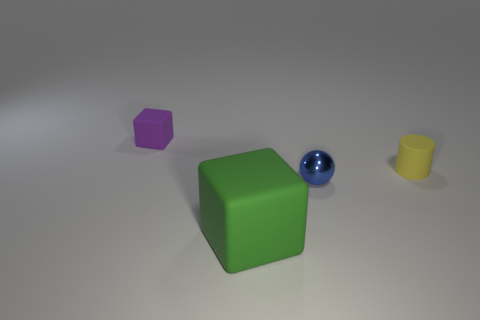There is a big block that is the same material as the tiny yellow thing; what color is it?
Provide a short and direct response. Green. There is a block behind the blue shiny thing; how big is it?
Offer a very short reply. Small. Is the number of green matte cubes that are behind the tiny purple cube less than the number of yellow objects?
Keep it short and to the point. Yes. Do the large matte cube and the small block have the same color?
Your answer should be very brief. No. Are there any other things that are the same shape as the tiny purple object?
Provide a short and direct response. Yes. Is the number of small purple blocks less than the number of tiny purple metal cubes?
Give a very brief answer. No. The small matte thing that is right of the small rubber object that is behind the tiny cylinder is what color?
Keep it short and to the point. Yellow. There is a cube on the right side of the tiny thing left of the block in front of the yellow cylinder; what is it made of?
Give a very brief answer. Rubber. Is the size of the cube that is behind the metal object the same as the blue thing?
Ensure brevity in your answer.  Yes. There is a block on the left side of the large rubber object; what is its material?
Keep it short and to the point. Rubber. 